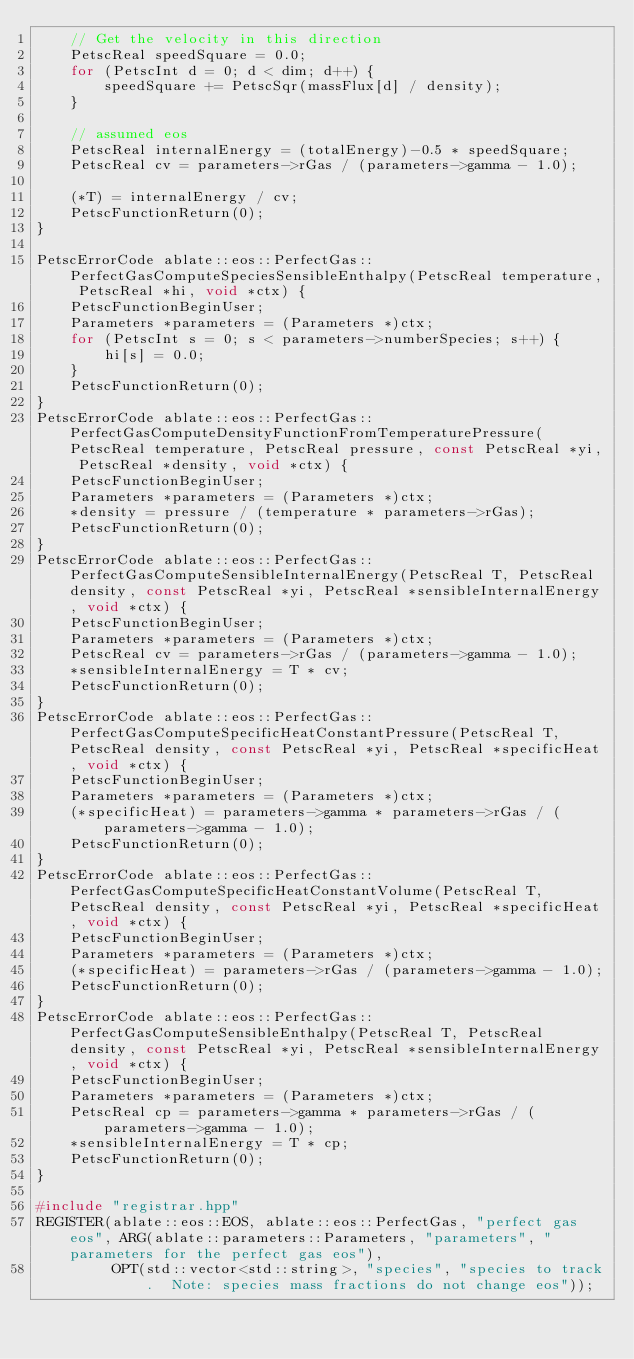Convert code to text. <code><loc_0><loc_0><loc_500><loc_500><_C++_>    // Get the velocity in this direction
    PetscReal speedSquare = 0.0;
    for (PetscInt d = 0; d < dim; d++) {
        speedSquare += PetscSqr(massFlux[d] / density);
    }

    // assumed eos
    PetscReal internalEnergy = (totalEnergy)-0.5 * speedSquare;
    PetscReal cv = parameters->rGas / (parameters->gamma - 1.0);

    (*T) = internalEnergy / cv;
    PetscFunctionReturn(0);
}

PetscErrorCode ablate::eos::PerfectGas::PerfectGasComputeSpeciesSensibleEnthalpy(PetscReal temperature, PetscReal *hi, void *ctx) {
    PetscFunctionBeginUser;
    Parameters *parameters = (Parameters *)ctx;
    for (PetscInt s = 0; s < parameters->numberSpecies; s++) {
        hi[s] = 0.0;
    }
    PetscFunctionReturn(0);
}
PetscErrorCode ablate::eos::PerfectGas::PerfectGasComputeDensityFunctionFromTemperaturePressure(PetscReal temperature, PetscReal pressure, const PetscReal *yi, PetscReal *density, void *ctx) {
    PetscFunctionBeginUser;
    Parameters *parameters = (Parameters *)ctx;
    *density = pressure / (temperature * parameters->rGas);
    PetscFunctionReturn(0);
}
PetscErrorCode ablate::eos::PerfectGas::PerfectGasComputeSensibleInternalEnergy(PetscReal T, PetscReal density, const PetscReal *yi, PetscReal *sensibleInternalEnergy, void *ctx) {
    PetscFunctionBeginUser;
    Parameters *parameters = (Parameters *)ctx;
    PetscReal cv = parameters->rGas / (parameters->gamma - 1.0);
    *sensibleInternalEnergy = T * cv;
    PetscFunctionReturn(0);
}
PetscErrorCode ablate::eos::PerfectGas::PerfectGasComputeSpecificHeatConstantPressure(PetscReal T, PetscReal density, const PetscReal *yi, PetscReal *specificHeat, void *ctx) {
    PetscFunctionBeginUser;
    Parameters *parameters = (Parameters *)ctx;
    (*specificHeat) = parameters->gamma * parameters->rGas / (parameters->gamma - 1.0);
    PetscFunctionReturn(0);
}
PetscErrorCode ablate::eos::PerfectGas::PerfectGasComputeSpecificHeatConstantVolume(PetscReal T, PetscReal density, const PetscReal *yi, PetscReal *specificHeat, void *ctx) {
    PetscFunctionBeginUser;
    Parameters *parameters = (Parameters *)ctx;
    (*specificHeat) = parameters->rGas / (parameters->gamma - 1.0);
    PetscFunctionReturn(0);
}
PetscErrorCode ablate::eos::PerfectGas::PerfectGasComputeSensibleEnthalpy(PetscReal T, PetscReal density, const PetscReal *yi, PetscReal *sensibleInternalEnergy, void *ctx) {
    PetscFunctionBeginUser;
    Parameters *parameters = (Parameters *)ctx;
    PetscReal cp = parameters->gamma * parameters->rGas / (parameters->gamma - 1.0);
    *sensibleInternalEnergy = T * cp;
    PetscFunctionReturn(0);
}

#include "registrar.hpp"
REGISTER(ablate::eos::EOS, ablate::eos::PerfectGas, "perfect gas eos", ARG(ablate::parameters::Parameters, "parameters", "parameters for the perfect gas eos"),
         OPT(std::vector<std::string>, "species", "species to track.  Note: species mass fractions do not change eos"));</code> 